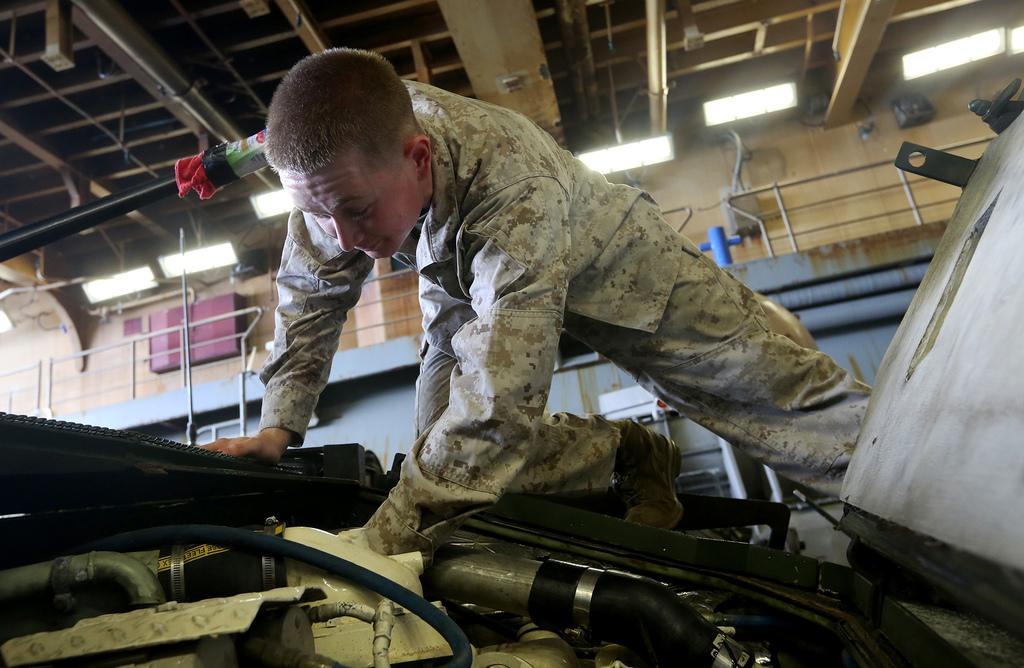Describe this image in one or two sentences. In this image we can see a person wearing dress is on the vehicle where we can see the engine. The background of the image is blurred, where we can see the ceiling. 